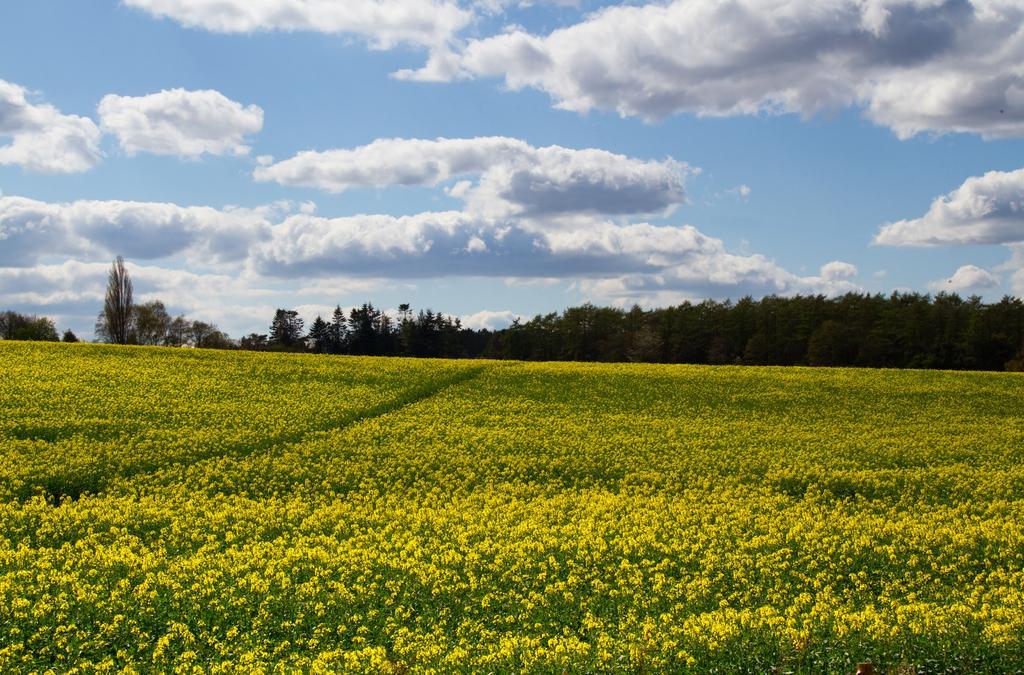How would you summarize this image in a sentence or two? In this picture I can see many flowers in the middle. In the background there are trees, at the top there is the sky. 